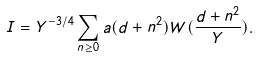<formula> <loc_0><loc_0><loc_500><loc_500>I = Y ^ { - 3 / 4 } \sum _ { n \geq 0 } a ( d + n ^ { 2 } ) W ( \frac { d + n ^ { 2 } } { Y } ) .</formula> 